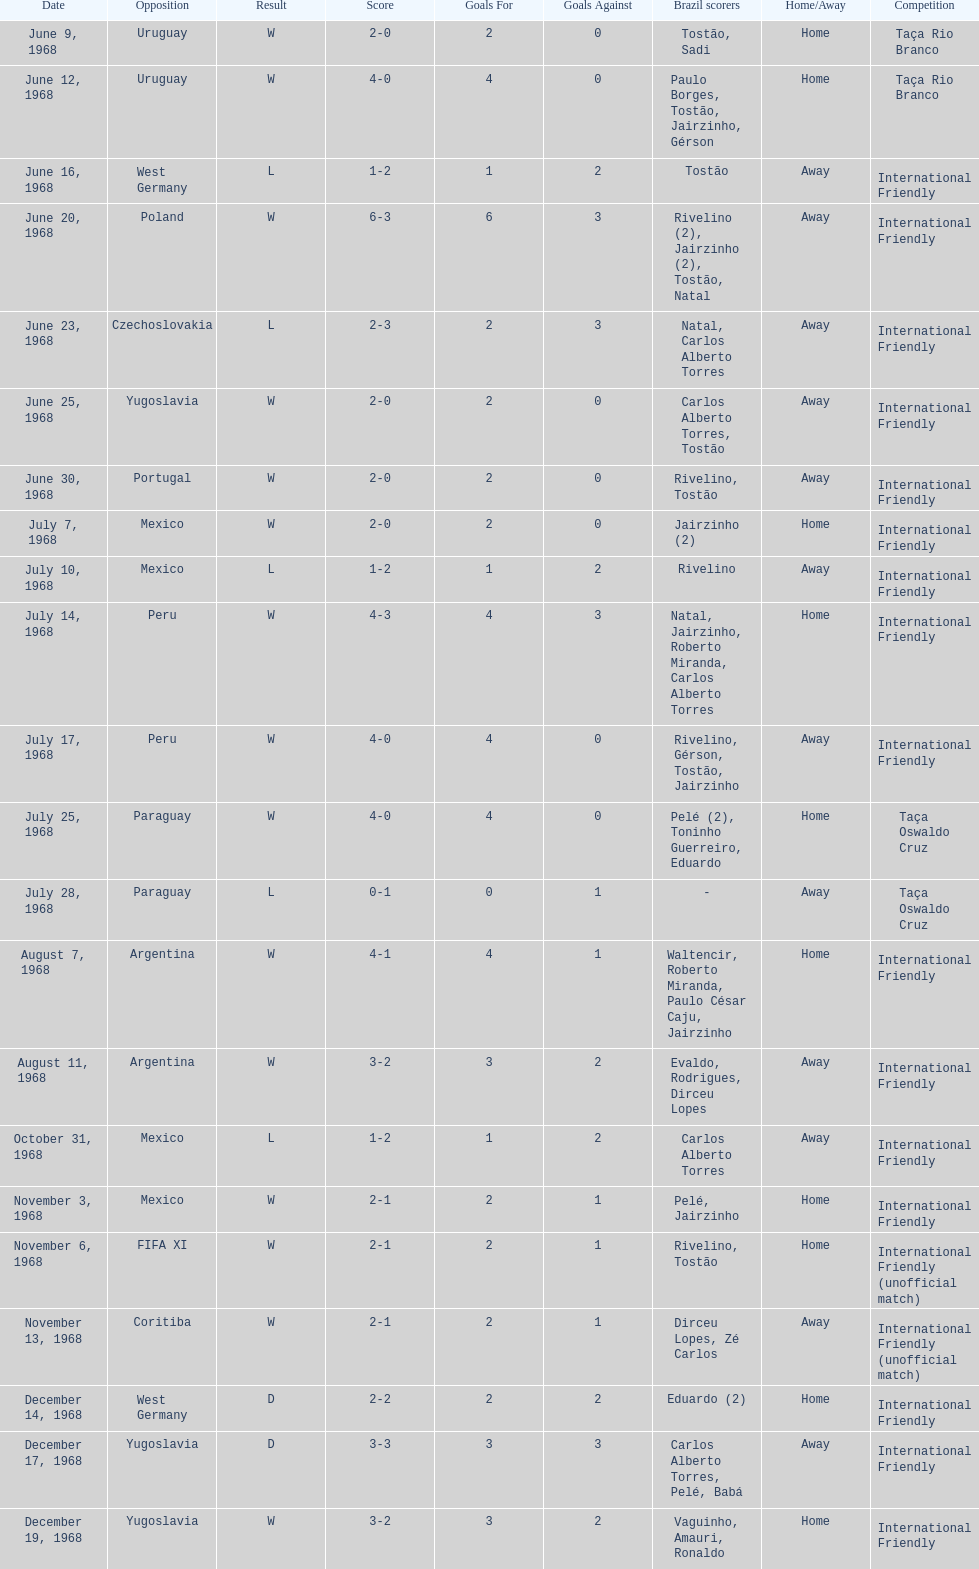Who played brazil previous to the game on june 30th? Yugoslavia. 